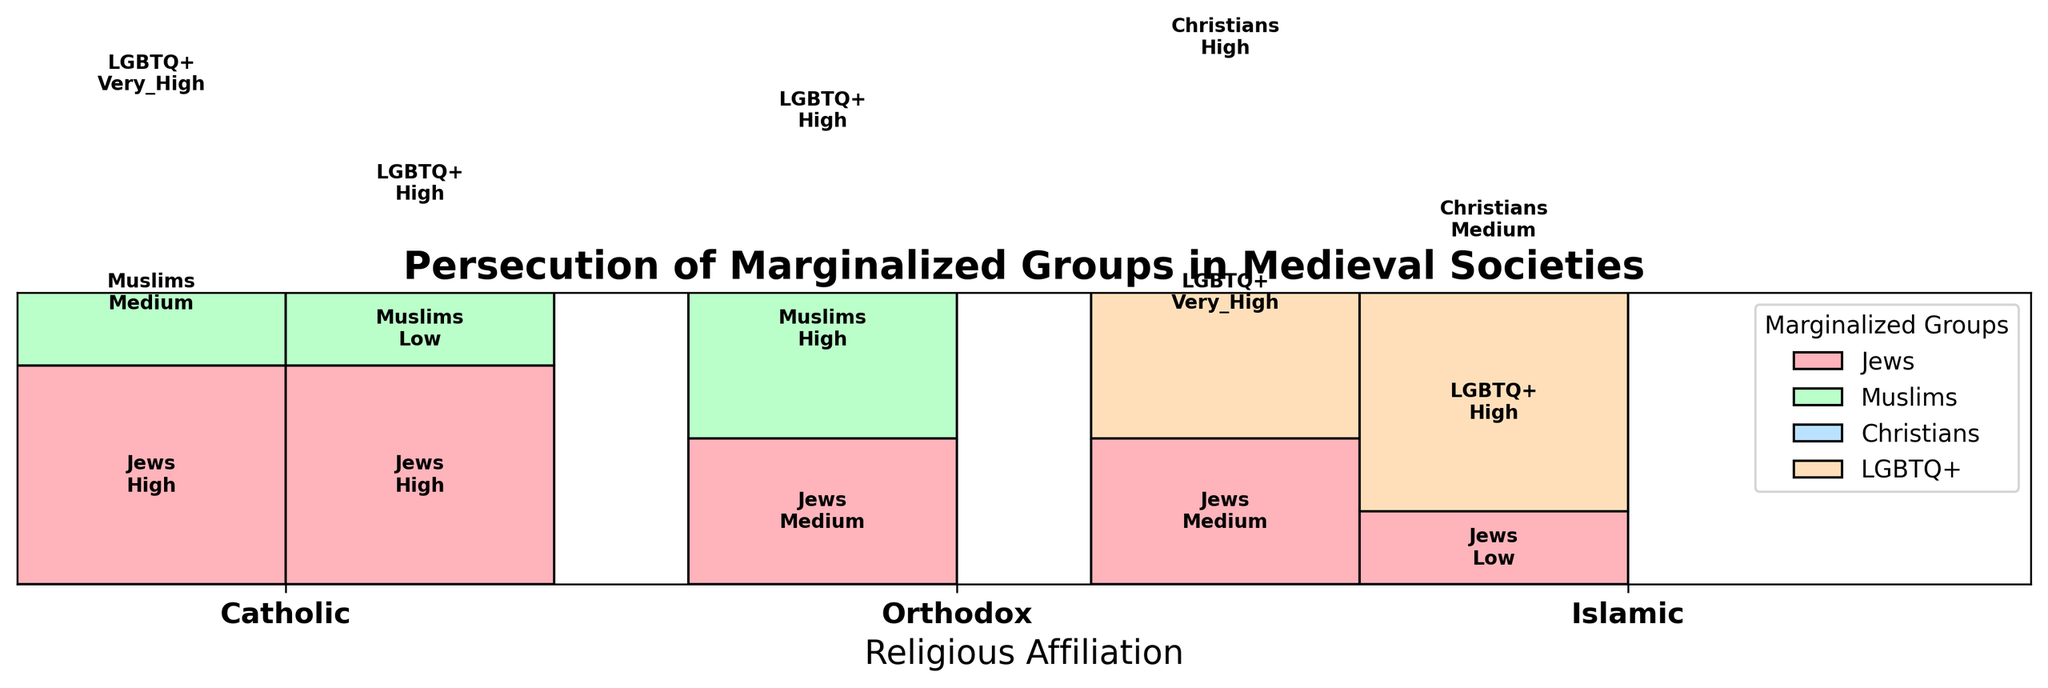What is the title of the figure? The title is usually located at the top and is often bolded to stand out. In this figure, it reads "Persecution of Marginalized Groups in Medieval Societies".
Answer: Persecution of Marginalized Groups in Medieval Societies Which marginalized group has the highest persecution level under Catholic, Capetian rule? Look for the Catholic, Capetian section, then identify the group with the highest vertical height or label "Very High".
Answer: LGBTQ+ How does the persecution level of Jews under the Islamic Umayyad dynasty compare to the Catholic Capetian dynasty? Compare the heights of the rectangles in the respective sections and note the labels for persecution levels. The Islamic Umayyad has "Medium", and the Catholic Capetian has "High".
Answer: Islamic Umayyad has Medium, Catholic Capetian has High What is the ruling dynasty with the lowest level of persecution toward Muslims? Identify the section for each ruling dynasty and locate the Muslim group's rectangle. The height and label will show the persecution level. The Plantagenet dynasty has "Low".
Answer: Plantagenet How many different marginalized groups are depicted in the plot? Count the unique group labels across the entire plot.
Answer: Four (Jews, Muslims, Christians, LGBTQ+) Under which religious affiliation do we see the most uniform levels of persecution across all marginalized groups? Look at each religious affiliation's section and compare the consistency of heights and labels. The Abbasid dynasty under Islamic rule shows relatively uniform levels (Low, Medium, High).
Answer: Islamic Abbasid Which marginalized group experienced "Very High" persecution across multiple ruling dynasties? Check for the instances labeled "Very High" across the dynasties for each marginalized group. LGBTQ+ has "Very High" under both Capetian and Umayyad.
Answer: LGBTQ+ Between the Capetian and Byzantine dynasties under their respective religious affiliations, which had a higher overall persecution level towards Muslims? Compare the labels or the heights of the rectangles for Muslims in Capetian (Medium) and Byzantine (High).
Answer: Byzantine How does the persecution of Christians under Islamic rule vary between the Umayyad and Abbasid dynasties? Check the rectangles for Christians under the Umayyad and Abbasid sections and compare their heights/labels. Umayyad is "High" and Abbasid is "Medium".
Answer: Umayyad is High, Abbasid is Medium What does the axis label on the x-axis indicate? Observe the text right beneath the x-axis, which describes the groups or categories being represented horizontally. It indicates "Religious Affiliation".
Answer: Religious Affiliation 